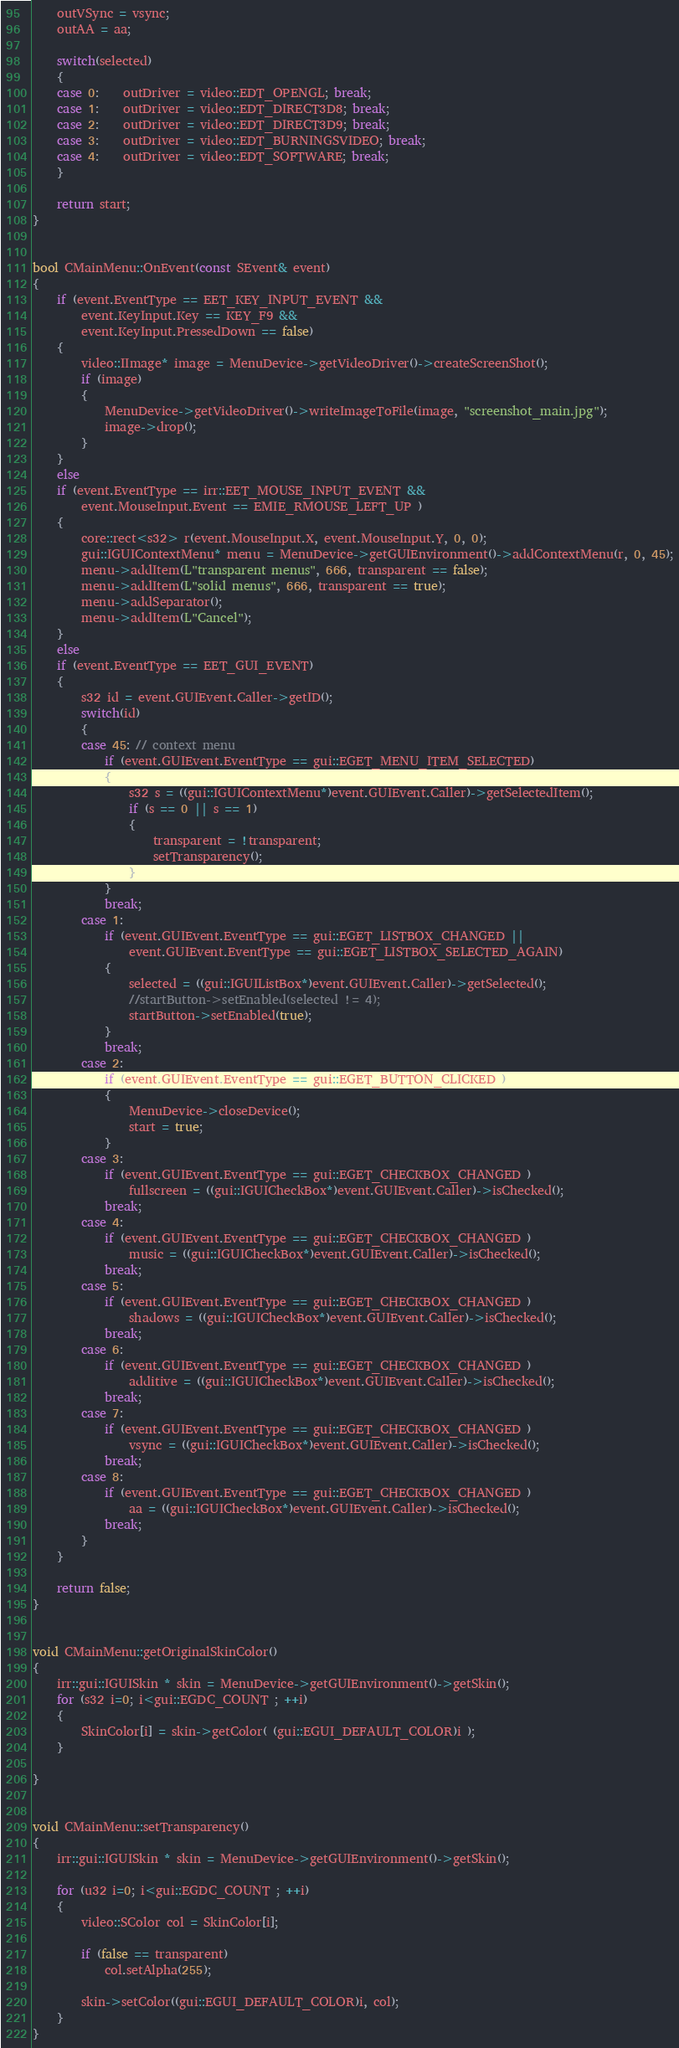<code> <loc_0><loc_0><loc_500><loc_500><_C++_>	outVSync = vsync;
	outAA = aa;

	switch(selected)
	{
	case 0:	outDriver = video::EDT_OPENGL; break;
	case 1:	outDriver = video::EDT_DIRECT3D8; break;
	case 2:	outDriver = video::EDT_DIRECT3D9; break;
	case 3:	outDriver = video::EDT_BURNINGSVIDEO; break;
	case 4:	outDriver = video::EDT_SOFTWARE; break;
	}

	return start;
}


bool CMainMenu::OnEvent(const SEvent& event)
{
	if (event.EventType == EET_KEY_INPUT_EVENT &&
		event.KeyInput.Key == KEY_F9 &&
		event.KeyInput.PressedDown == false)
	{
		video::IImage* image = MenuDevice->getVideoDriver()->createScreenShot();
		if (image)
		{
			MenuDevice->getVideoDriver()->writeImageToFile(image, "screenshot_main.jpg");
			image->drop();
		}
	}
	else
	if (event.EventType == irr::EET_MOUSE_INPUT_EVENT &&
		event.MouseInput.Event == EMIE_RMOUSE_LEFT_UP )
	{
		core::rect<s32> r(event.MouseInput.X, event.MouseInput.Y, 0, 0);
		gui::IGUIContextMenu* menu = MenuDevice->getGUIEnvironment()->addContextMenu(r, 0, 45);
		menu->addItem(L"transparent menus", 666, transparent == false);
		menu->addItem(L"solid menus", 666, transparent == true);
		menu->addSeparator();
		menu->addItem(L"Cancel");
	}
	else
	if (event.EventType == EET_GUI_EVENT)
	{
		s32 id = event.GUIEvent.Caller->getID();
		switch(id)
		{
		case 45: // context menu
			if (event.GUIEvent.EventType == gui::EGET_MENU_ITEM_SELECTED)
			{
				s32 s = ((gui::IGUIContextMenu*)event.GUIEvent.Caller)->getSelectedItem();
				if (s == 0 || s == 1)
				{
					transparent = !transparent;
					setTransparency();
				}
			}
			break;
		case 1:
			if (event.GUIEvent.EventType == gui::EGET_LISTBOX_CHANGED ||
				event.GUIEvent.EventType == gui::EGET_LISTBOX_SELECTED_AGAIN)
			{
				selected = ((gui::IGUIListBox*)event.GUIEvent.Caller)->getSelected();
				//startButton->setEnabled(selected != 4);
				startButton->setEnabled(true);
			}
			break;
		case 2:
			if (event.GUIEvent.EventType == gui::EGET_BUTTON_CLICKED )
			{
				MenuDevice->closeDevice();
				start = true;
			}
		case 3:
			if (event.GUIEvent.EventType == gui::EGET_CHECKBOX_CHANGED )
				fullscreen = ((gui::IGUICheckBox*)event.GUIEvent.Caller)->isChecked();
			break;
		case 4:
			if (event.GUIEvent.EventType == gui::EGET_CHECKBOX_CHANGED )
				music = ((gui::IGUICheckBox*)event.GUIEvent.Caller)->isChecked();
			break;
		case 5:
			if (event.GUIEvent.EventType == gui::EGET_CHECKBOX_CHANGED )
				shadows = ((gui::IGUICheckBox*)event.GUIEvent.Caller)->isChecked();
			break;
		case 6:
			if (event.GUIEvent.EventType == gui::EGET_CHECKBOX_CHANGED )
				additive = ((gui::IGUICheckBox*)event.GUIEvent.Caller)->isChecked();
			break;
		case 7:
			if (event.GUIEvent.EventType == gui::EGET_CHECKBOX_CHANGED )
				vsync = ((gui::IGUICheckBox*)event.GUIEvent.Caller)->isChecked();
			break;
		case 8:
			if (event.GUIEvent.EventType == gui::EGET_CHECKBOX_CHANGED )
				aa = ((gui::IGUICheckBox*)event.GUIEvent.Caller)->isChecked();
			break;
		}
	}

	return false;
}


void CMainMenu::getOriginalSkinColor()
{
	irr::gui::IGUISkin * skin = MenuDevice->getGUIEnvironment()->getSkin();
	for (s32 i=0; i<gui::EGDC_COUNT ; ++i)
	{
		SkinColor[i] = skin->getColor( (gui::EGUI_DEFAULT_COLOR)i );
	}

}


void CMainMenu::setTransparency()
{
	irr::gui::IGUISkin * skin = MenuDevice->getGUIEnvironment()->getSkin();

	for (u32 i=0; i<gui::EGDC_COUNT ; ++i)
	{
		video::SColor col = SkinColor[i];

		if (false == transparent)
			col.setAlpha(255);

		skin->setColor((gui::EGUI_DEFAULT_COLOR)i, col);
	}
}

</code> 